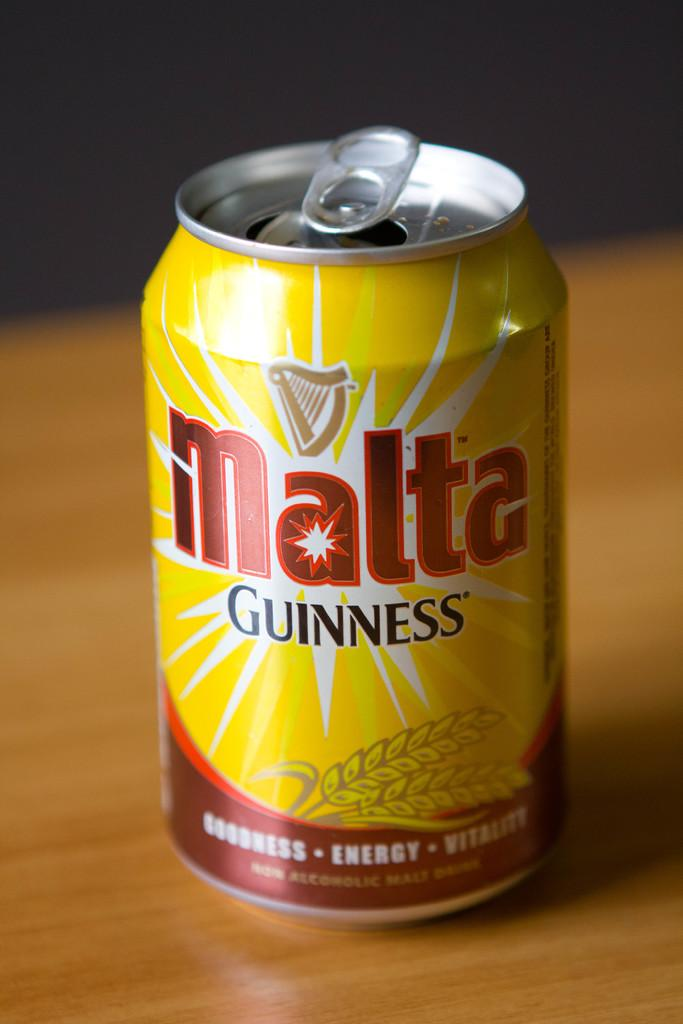<image>
Present a compact description of the photo's key features. A can of malta Guiness contains a non-alcoholic malt drink. 